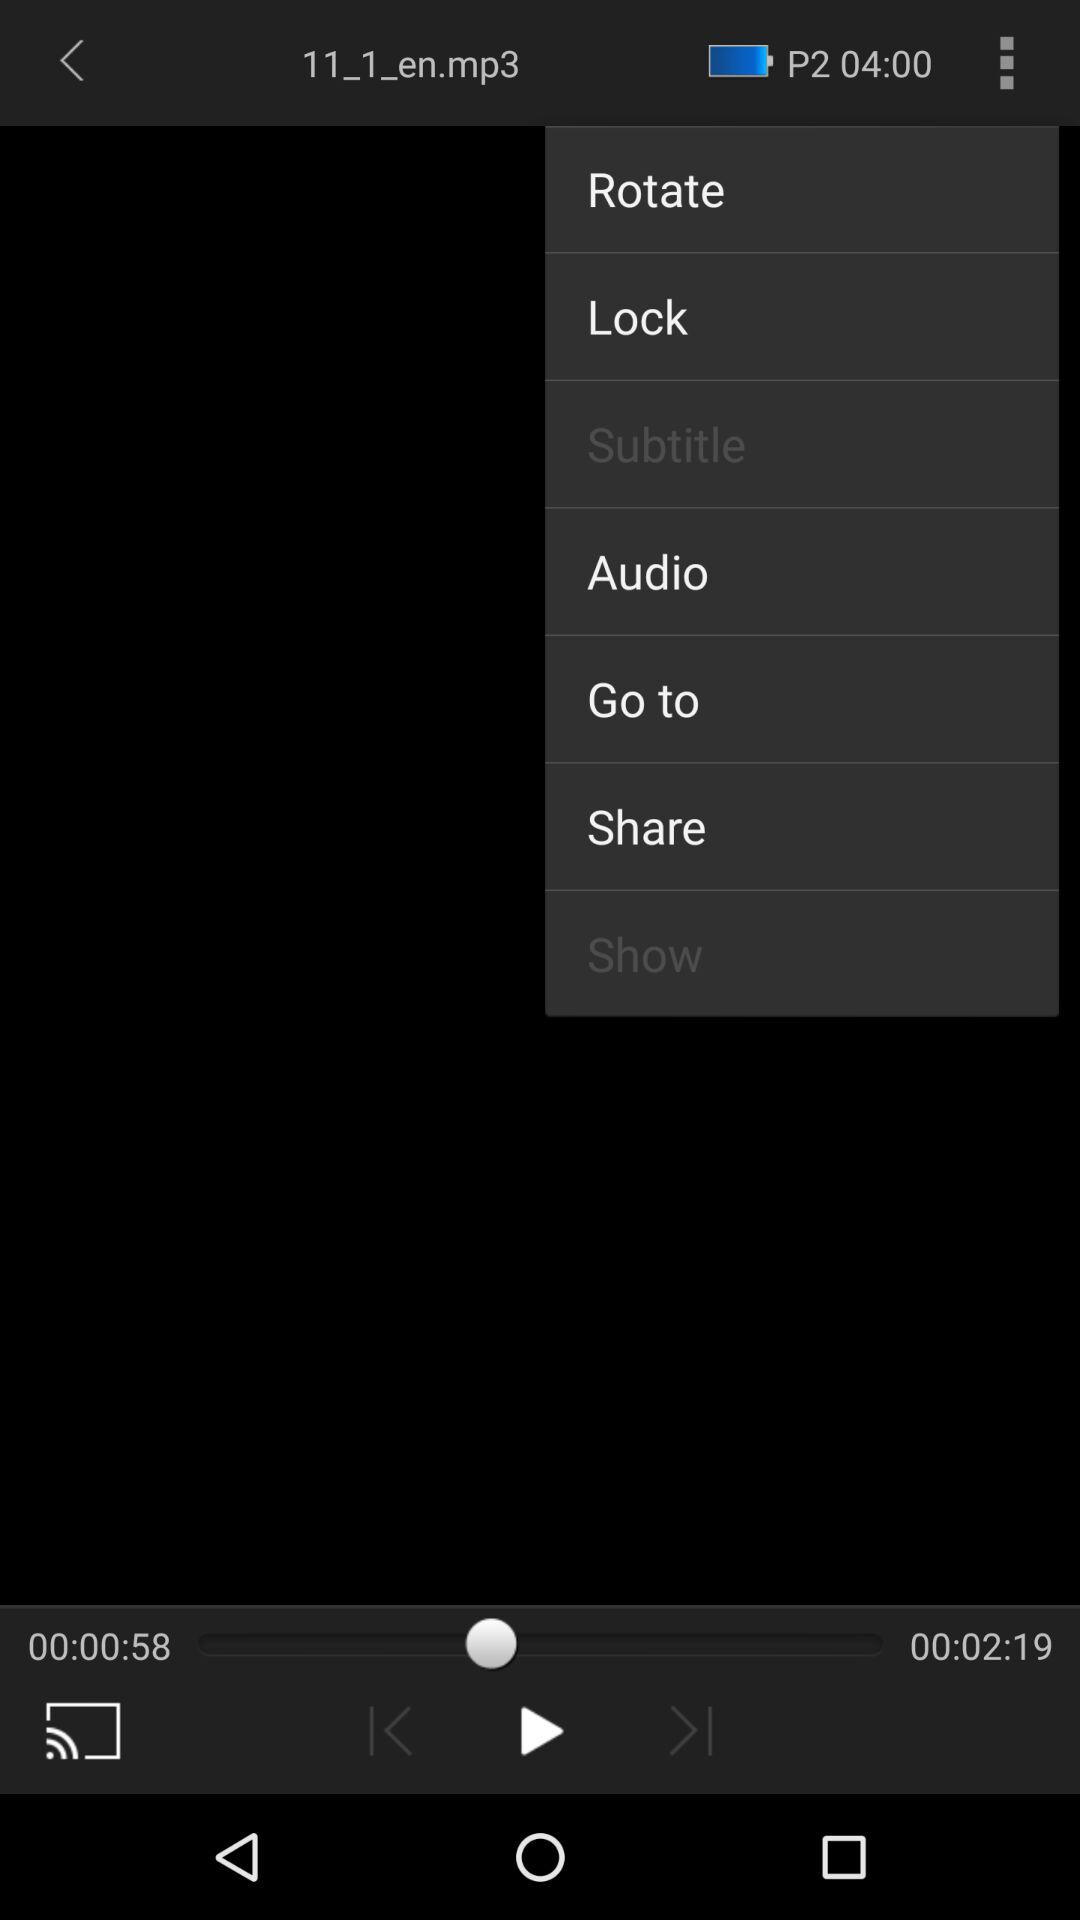Which languages are the subtitles available in?
When the provided information is insufficient, respond with <no answer>. <no answer> 